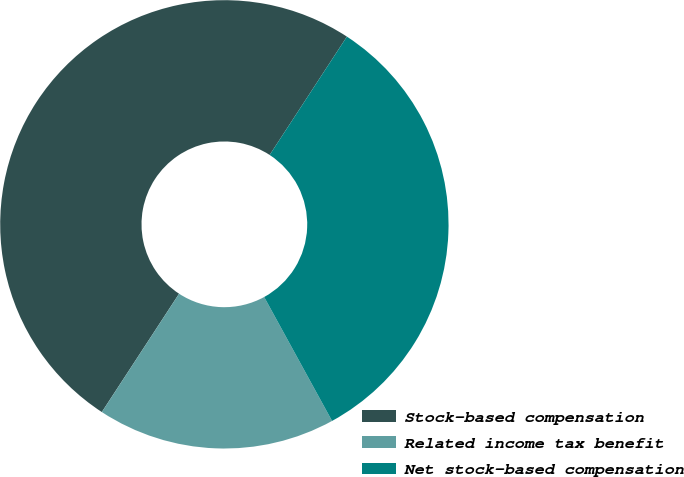Convert chart to OTSL. <chart><loc_0><loc_0><loc_500><loc_500><pie_chart><fcel>Stock-based compensation<fcel>Related income tax benefit<fcel>Net stock-based compensation<nl><fcel>50.0%<fcel>17.18%<fcel>32.82%<nl></chart> 